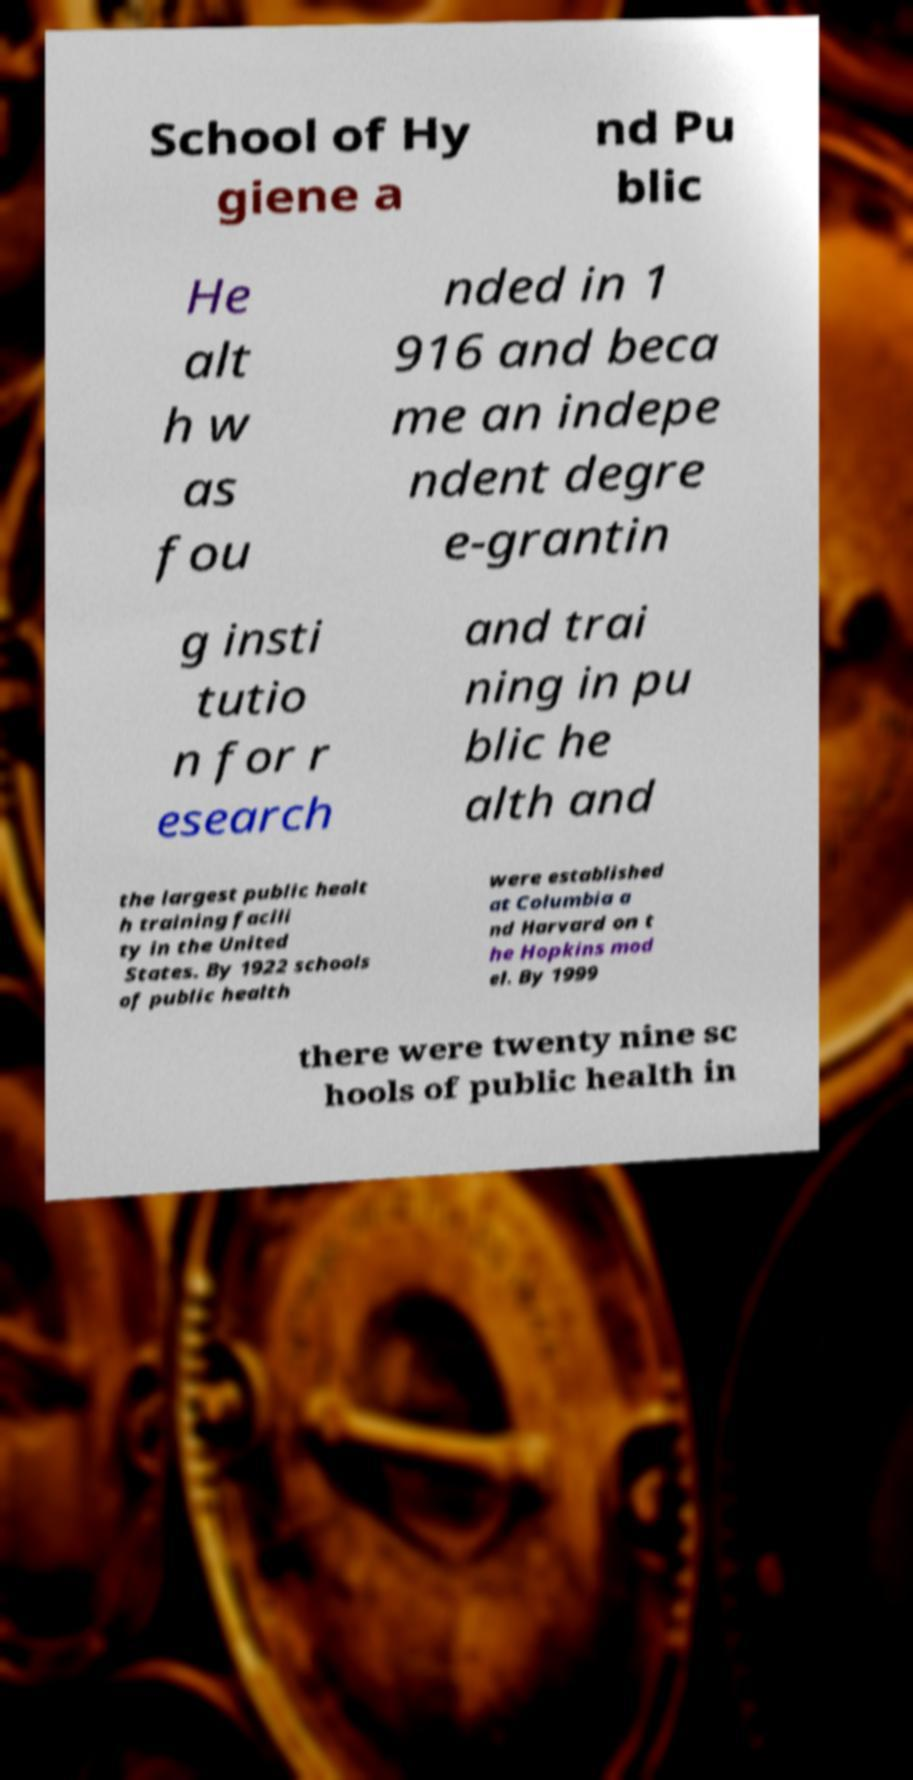Can you read and provide the text displayed in the image?This photo seems to have some interesting text. Can you extract and type it out for me? School of Hy giene a nd Pu blic He alt h w as fou nded in 1 916 and beca me an indepe ndent degre e-grantin g insti tutio n for r esearch and trai ning in pu blic he alth and the largest public healt h training facili ty in the United States. By 1922 schools of public health were established at Columbia a nd Harvard on t he Hopkins mod el. By 1999 there were twenty nine sc hools of public health in 